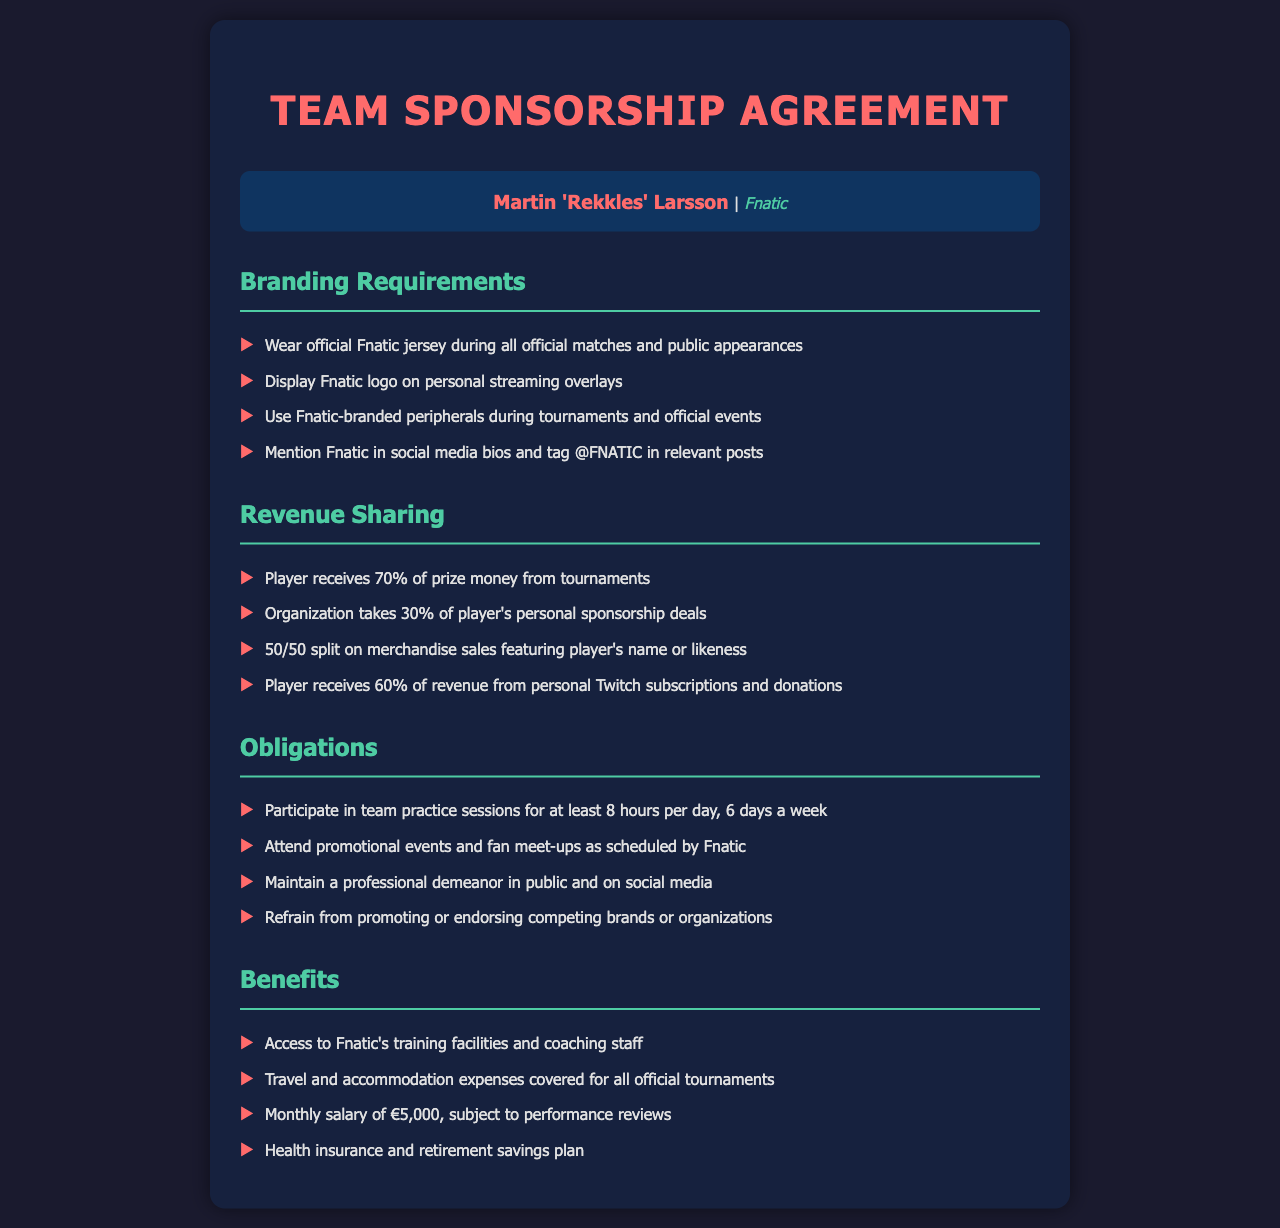What percentage of prize money does the player receive? The document states that the player receives 70% of prize money from tournaments.
Answer: 70% What must players refrain from promoting? The obligations section mentions that players must refrain from promoting competing brands or organizations.
Answer: Competing brands What is the player's monthly salary? The benefits section specifies that the player receives a monthly salary of €5,000.
Answer: €5,000 How many hours per day are players required to practice? The obligations mention that players must participate in team practice sessions for at least 8 hours per day.
Answer: 8 hours What is the revenue split on merchandise sales featuring the player's name? The revenue sharing section states a 50/50 split on merchandise sales featuring the player's name or likeness.
Answer: 50/50 split What organization is this sponsorship agreement with? The player's name indicates the organization involved in the agreement.
Answer: Fnatic What type of events must players attend? The obligations state that players must attend promotional events and fan meet-ups as scheduled by Fnatic.
Answer: Promotional events What cover travel and accommodation expenses? The benefits section mentions that travel and accommodation expenses are covered for all official tournaments.
Answer: All official tournaments 